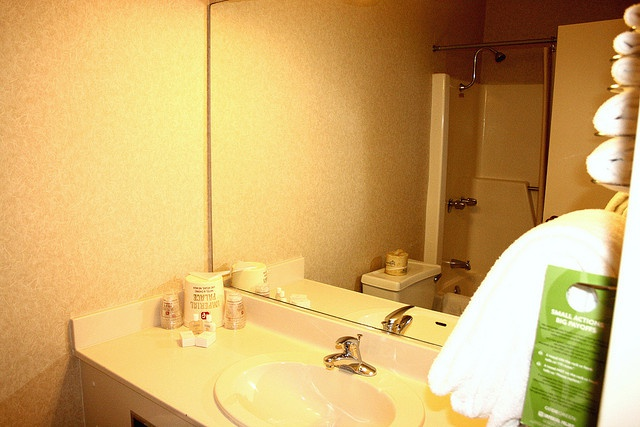Describe the objects in this image and their specific colors. I can see sink in orange, khaki, tan, and olive tones, toilet in orange, olive, tan, and maroon tones, and cup in orange and khaki tones in this image. 